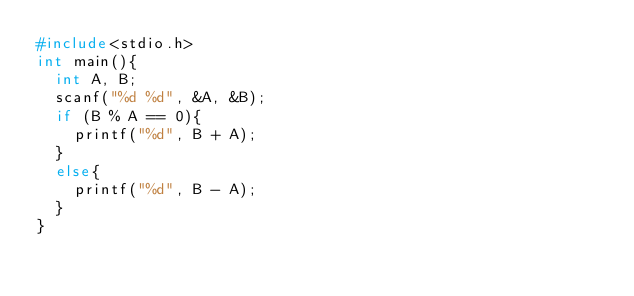<code> <loc_0><loc_0><loc_500><loc_500><_C_>#include<stdio.h>
int main(){
  int A, B;
  scanf("%d %d", &A, &B);
  if (B % A == 0){
    printf("%d", B + A);
  }
  else{
    printf("%d", B - A);
  }
}</code> 